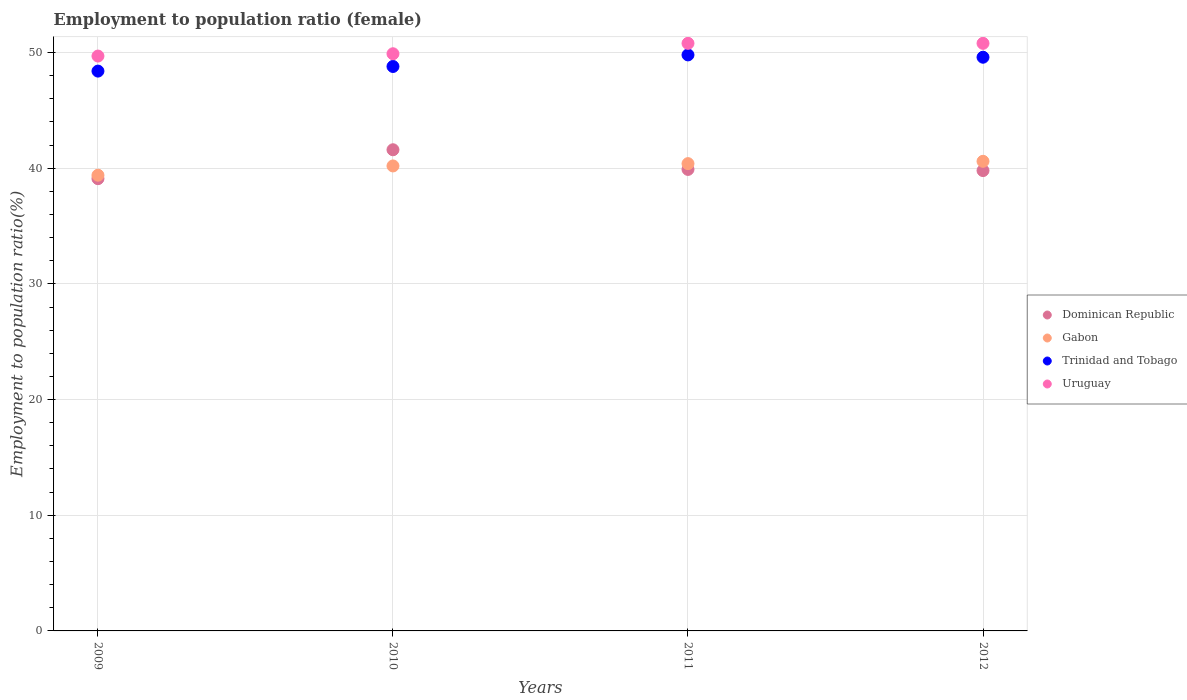Is the number of dotlines equal to the number of legend labels?
Give a very brief answer. Yes. What is the employment to population ratio in Dominican Republic in 2010?
Ensure brevity in your answer.  41.6. Across all years, what is the maximum employment to population ratio in Dominican Republic?
Ensure brevity in your answer.  41.6. Across all years, what is the minimum employment to population ratio in Uruguay?
Your answer should be compact. 49.7. What is the total employment to population ratio in Dominican Republic in the graph?
Offer a very short reply. 160.4. What is the difference between the employment to population ratio in Uruguay in 2009 and that in 2012?
Your answer should be very brief. -1.1. What is the difference between the employment to population ratio in Dominican Republic in 2011 and the employment to population ratio in Trinidad and Tobago in 2012?
Offer a terse response. -9.7. What is the average employment to population ratio in Gabon per year?
Keep it short and to the point. 40.15. In the year 2010, what is the difference between the employment to population ratio in Gabon and employment to population ratio in Trinidad and Tobago?
Offer a terse response. -8.6. In how many years, is the employment to population ratio in Uruguay greater than 28 %?
Your answer should be very brief. 4. What is the ratio of the employment to population ratio in Uruguay in 2010 to that in 2012?
Give a very brief answer. 0.98. Is the difference between the employment to population ratio in Gabon in 2010 and 2011 greater than the difference between the employment to population ratio in Trinidad and Tobago in 2010 and 2011?
Give a very brief answer. Yes. What is the difference between the highest and the second highest employment to population ratio in Uruguay?
Ensure brevity in your answer.  0. What is the difference between the highest and the lowest employment to population ratio in Gabon?
Offer a very short reply. 1.2. In how many years, is the employment to population ratio in Gabon greater than the average employment to population ratio in Gabon taken over all years?
Give a very brief answer. 3. Is the sum of the employment to population ratio in Dominican Republic in 2010 and 2011 greater than the maximum employment to population ratio in Trinidad and Tobago across all years?
Your answer should be very brief. Yes. Is it the case that in every year, the sum of the employment to population ratio in Gabon and employment to population ratio in Trinidad and Tobago  is greater than the employment to population ratio in Uruguay?
Ensure brevity in your answer.  Yes. Is the employment to population ratio in Uruguay strictly greater than the employment to population ratio in Trinidad and Tobago over the years?
Give a very brief answer. Yes. How many years are there in the graph?
Keep it short and to the point. 4. Are the values on the major ticks of Y-axis written in scientific E-notation?
Make the answer very short. No. Does the graph contain any zero values?
Offer a terse response. No. Where does the legend appear in the graph?
Your response must be concise. Center right. How are the legend labels stacked?
Provide a short and direct response. Vertical. What is the title of the graph?
Ensure brevity in your answer.  Employment to population ratio (female). Does "Sierra Leone" appear as one of the legend labels in the graph?
Offer a terse response. No. What is the Employment to population ratio(%) of Dominican Republic in 2009?
Offer a terse response. 39.1. What is the Employment to population ratio(%) of Gabon in 2009?
Offer a very short reply. 39.4. What is the Employment to population ratio(%) of Trinidad and Tobago in 2009?
Give a very brief answer. 48.4. What is the Employment to population ratio(%) in Uruguay in 2009?
Provide a short and direct response. 49.7. What is the Employment to population ratio(%) of Dominican Republic in 2010?
Give a very brief answer. 41.6. What is the Employment to population ratio(%) of Gabon in 2010?
Offer a very short reply. 40.2. What is the Employment to population ratio(%) of Trinidad and Tobago in 2010?
Ensure brevity in your answer.  48.8. What is the Employment to population ratio(%) in Uruguay in 2010?
Your answer should be very brief. 49.9. What is the Employment to population ratio(%) in Dominican Republic in 2011?
Provide a succinct answer. 39.9. What is the Employment to population ratio(%) in Gabon in 2011?
Offer a terse response. 40.4. What is the Employment to population ratio(%) of Trinidad and Tobago in 2011?
Offer a very short reply. 49.8. What is the Employment to population ratio(%) in Uruguay in 2011?
Ensure brevity in your answer.  50.8. What is the Employment to population ratio(%) of Dominican Republic in 2012?
Your response must be concise. 39.8. What is the Employment to population ratio(%) of Gabon in 2012?
Keep it short and to the point. 40.6. What is the Employment to population ratio(%) in Trinidad and Tobago in 2012?
Your response must be concise. 49.6. What is the Employment to population ratio(%) in Uruguay in 2012?
Provide a succinct answer. 50.8. Across all years, what is the maximum Employment to population ratio(%) in Dominican Republic?
Your answer should be very brief. 41.6. Across all years, what is the maximum Employment to population ratio(%) in Gabon?
Keep it short and to the point. 40.6. Across all years, what is the maximum Employment to population ratio(%) of Trinidad and Tobago?
Your response must be concise. 49.8. Across all years, what is the maximum Employment to population ratio(%) of Uruguay?
Offer a terse response. 50.8. Across all years, what is the minimum Employment to population ratio(%) in Dominican Republic?
Ensure brevity in your answer.  39.1. Across all years, what is the minimum Employment to population ratio(%) in Gabon?
Your response must be concise. 39.4. Across all years, what is the minimum Employment to population ratio(%) in Trinidad and Tobago?
Give a very brief answer. 48.4. Across all years, what is the minimum Employment to population ratio(%) of Uruguay?
Give a very brief answer. 49.7. What is the total Employment to population ratio(%) in Dominican Republic in the graph?
Your response must be concise. 160.4. What is the total Employment to population ratio(%) of Gabon in the graph?
Provide a succinct answer. 160.6. What is the total Employment to population ratio(%) of Trinidad and Tobago in the graph?
Make the answer very short. 196.6. What is the total Employment to population ratio(%) in Uruguay in the graph?
Give a very brief answer. 201.2. What is the difference between the Employment to population ratio(%) of Dominican Republic in 2009 and that in 2011?
Keep it short and to the point. -0.8. What is the difference between the Employment to population ratio(%) in Gabon in 2009 and that in 2011?
Ensure brevity in your answer.  -1. What is the difference between the Employment to population ratio(%) of Uruguay in 2009 and that in 2011?
Your answer should be very brief. -1.1. What is the difference between the Employment to population ratio(%) in Dominican Republic in 2009 and that in 2012?
Offer a terse response. -0.7. What is the difference between the Employment to population ratio(%) of Trinidad and Tobago in 2009 and that in 2012?
Your response must be concise. -1.2. What is the difference between the Employment to population ratio(%) in Uruguay in 2009 and that in 2012?
Provide a short and direct response. -1.1. What is the difference between the Employment to population ratio(%) in Trinidad and Tobago in 2010 and that in 2011?
Ensure brevity in your answer.  -1. What is the difference between the Employment to population ratio(%) of Gabon in 2010 and that in 2012?
Offer a very short reply. -0.4. What is the difference between the Employment to population ratio(%) of Dominican Republic in 2011 and that in 2012?
Keep it short and to the point. 0.1. What is the difference between the Employment to population ratio(%) in Trinidad and Tobago in 2011 and that in 2012?
Offer a very short reply. 0.2. What is the difference between the Employment to population ratio(%) of Dominican Republic in 2009 and the Employment to population ratio(%) of Trinidad and Tobago in 2010?
Ensure brevity in your answer.  -9.7. What is the difference between the Employment to population ratio(%) in Dominican Republic in 2009 and the Employment to population ratio(%) in Uruguay in 2010?
Give a very brief answer. -10.8. What is the difference between the Employment to population ratio(%) of Gabon in 2009 and the Employment to population ratio(%) of Trinidad and Tobago in 2010?
Your answer should be compact. -9.4. What is the difference between the Employment to population ratio(%) in Gabon in 2009 and the Employment to population ratio(%) in Uruguay in 2010?
Offer a terse response. -10.5. What is the difference between the Employment to population ratio(%) in Trinidad and Tobago in 2009 and the Employment to population ratio(%) in Uruguay in 2010?
Make the answer very short. -1.5. What is the difference between the Employment to population ratio(%) in Dominican Republic in 2009 and the Employment to population ratio(%) in Trinidad and Tobago in 2011?
Your response must be concise. -10.7. What is the difference between the Employment to population ratio(%) in Gabon in 2009 and the Employment to population ratio(%) in Trinidad and Tobago in 2011?
Offer a terse response. -10.4. What is the difference between the Employment to population ratio(%) of Gabon in 2009 and the Employment to population ratio(%) of Uruguay in 2011?
Provide a succinct answer. -11.4. What is the difference between the Employment to population ratio(%) of Trinidad and Tobago in 2009 and the Employment to population ratio(%) of Uruguay in 2011?
Your answer should be compact. -2.4. What is the difference between the Employment to population ratio(%) in Dominican Republic in 2009 and the Employment to population ratio(%) in Uruguay in 2012?
Provide a succinct answer. -11.7. What is the difference between the Employment to population ratio(%) in Gabon in 2009 and the Employment to population ratio(%) in Trinidad and Tobago in 2012?
Ensure brevity in your answer.  -10.2. What is the difference between the Employment to population ratio(%) of Trinidad and Tobago in 2009 and the Employment to population ratio(%) of Uruguay in 2012?
Your response must be concise. -2.4. What is the difference between the Employment to population ratio(%) in Dominican Republic in 2010 and the Employment to population ratio(%) in Gabon in 2011?
Offer a terse response. 1.2. What is the difference between the Employment to population ratio(%) of Gabon in 2010 and the Employment to population ratio(%) of Trinidad and Tobago in 2011?
Offer a very short reply. -9.6. What is the difference between the Employment to population ratio(%) of Dominican Republic in 2010 and the Employment to population ratio(%) of Trinidad and Tobago in 2012?
Your answer should be very brief. -8. What is the difference between the Employment to population ratio(%) of Dominican Republic in 2011 and the Employment to population ratio(%) of Trinidad and Tobago in 2012?
Your response must be concise. -9.7. What is the difference between the Employment to population ratio(%) in Dominican Republic in 2011 and the Employment to population ratio(%) in Uruguay in 2012?
Your response must be concise. -10.9. What is the average Employment to population ratio(%) in Dominican Republic per year?
Ensure brevity in your answer.  40.1. What is the average Employment to population ratio(%) in Gabon per year?
Provide a short and direct response. 40.15. What is the average Employment to population ratio(%) in Trinidad and Tobago per year?
Ensure brevity in your answer.  49.15. What is the average Employment to population ratio(%) in Uruguay per year?
Provide a succinct answer. 50.3. In the year 2009, what is the difference between the Employment to population ratio(%) in Dominican Republic and Employment to population ratio(%) in Gabon?
Provide a succinct answer. -0.3. In the year 2009, what is the difference between the Employment to population ratio(%) in Trinidad and Tobago and Employment to population ratio(%) in Uruguay?
Your response must be concise. -1.3. In the year 2010, what is the difference between the Employment to population ratio(%) of Dominican Republic and Employment to population ratio(%) of Trinidad and Tobago?
Offer a very short reply. -7.2. In the year 2010, what is the difference between the Employment to population ratio(%) of Gabon and Employment to population ratio(%) of Uruguay?
Give a very brief answer. -9.7. In the year 2011, what is the difference between the Employment to population ratio(%) in Dominican Republic and Employment to population ratio(%) in Gabon?
Offer a very short reply. -0.5. In the year 2011, what is the difference between the Employment to population ratio(%) in Dominican Republic and Employment to population ratio(%) in Trinidad and Tobago?
Offer a very short reply. -9.9. In the year 2011, what is the difference between the Employment to population ratio(%) of Dominican Republic and Employment to population ratio(%) of Uruguay?
Give a very brief answer. -10.9. In the year 2011, what is the difference between the Employment to population ratio(%) of Gabon and Employment to population ratio(%) of Trinidad and Tobago?
Provide a succinct answer. -9.4. In the year 2011, what is the difference between the Employment to population ratio(%) of Gabon and Employment to population ratio(%) of Uruguay?
Keep it short and to the point. -10.4. In the year 2012, what is the difference between the Employment to population ratio(%) of Dominican Republic and Employment to population ratio(%) of Gabon?
Keep it short and to the point. -0.8. In the year 2012, what is the difference between the Employment to population ratio(%) in Dominican Republic and Employment to population ratio(%) in Uruguay?
Keep it short and to the point. -11. In the year 2012, what is the difference between the Employment to population ratio(%) of Gabon and Employment to population ratio(%) of Trinidad and Tobago?
Ensure brevity in your answer.  -9. What is the ratio of the Employment to population ratio(%) in Dominican Republic in 2009 to that in 2010?
Provide a succinct answer. 0.94. What is the ratio of the Employment to population ratio(%) of Gabon in 2009 to that in 2010?
Ensure brevity in your answer.  0.98. What is the ratio of the Employment to population ratio(%) in Trinidad and Tobago in 2009 to that in 2010?
Your answer should be compact. 0.99. What is the ratio of the Employment to population ratio(%) in Uruguay in 2009 to that in 2010?
Offer a very short reply. 1. What is the ratio of the Employment to population ratio(%) of Dominican Republic in 2009 to that in 2011?
Give a very brief answer. 0.98. What is the ratio of the Employment to population ratio(%) in Gabon in 2009 to that in 2011?
Your answer should be compact. 0.98. What is the ratio of the Employment to population ratio(%) in Trinidad and Tobago in 2009 to that in 2011?
Keep it short and to the point. 0.97. What is the ratio of the Employment to population ratio(%) in Uruguay in 2009 to that in 2011?
Ensure brevity in your answer.  0.98. What is the ratio of the Employment to population ratio(%) of Dominican Republic in 2009 to that in 2012?
Your answer should be very brief. 0.98. What is the ratio of the Employment to population ratio(%) in Gabon in 2009 to that in 2012?
Ensure brevity in your answer.  0.97. What is the ratio of the Employment to population ratio(%) of Trinidad and Tobago in 2009 to that in 2012?
Provide a short and direct response. 0.98. What is the ratio of the Employment to population ratio(%) in Uruguay in 2009 to that in 2012?
Your response must be concise. 0.98. What is the ratio of the Employment to population ratio(%) in Dominican Republic in 2010 to that in 2011?
Your answer should be very brief. 1.04. What is the ratio of the Employment to population ratio(%) of Trinidad and Tobago in 2010 to that in 2011?
Keep it short and to the point. 0.98. What is the ratio of the Employment to population ratio(%) in Uruguay in 2010 to that in 2011?
Provide a short and direct response. 0.98. What is the ratio of the Employment to population ratio(%) in Dominican Republic in 2010 to that in 2012?
Offer a terse response. 1.05. What is the ratio of the Employment to population ratio(%) of Trinidad and Tobago in 2010 to that in 2012?
Make the answer very short. 0.98. What is the ratio of the Employment to population ratio(%) of Uruguay in 2010 to that in 2012?
Offer a very short reply. 0.98. What is the ratio of the Employment to population ratio(%) of Dominican Republic in 2011 to that in 2012?
Offer a very short reply. 1. What is the ratio of the Employment to population ratio(%) in Uruguay in 2011 to that in 2012?
Your response must be concise. 1. What is the difference between the highest and the second highest Employment to population ratio(%) in Uruguay?
Keep it short and to the point. 0. What is the difference between the highest and the lowest Employment to population ratio(%) of Gabon?
Provide a succinct answer. 1.2. 